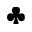Convert formula to latex. <formula><loc_0><loc_0><loc_500><loc_500>\clubsuit</formula> 